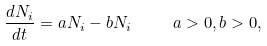<formula> <loc_0><loc_0><loc_500><loc_500>\frac { d N _ { i } } { d t } = a N _ { i } - b N _ { i } \quad \ a > 0 , b > 0 ,</formula> 